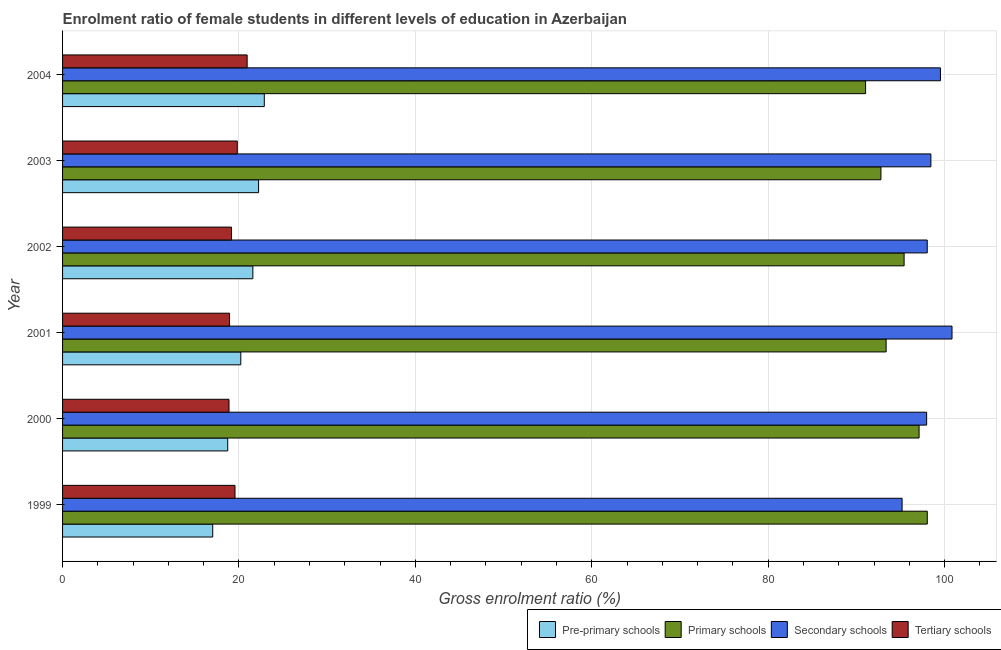How many different coloured bars are there?
Offer a terse response. 4. What is the gross enrolment ratio(male) in tertiary schools in 2001?
Provide a succinct answer. 18.93. Across all years, what is the maximum gross enrolment ratio(male) in tertiary schools?
Provide a succinct answer. 20.93. Across all years, what is the minimum gross enrolment ratio(male) in primary schools?
Your answer should be compact. 91.04. What is the total gross enrolment ratio(male) in primary schools in the graph?
Give a very brief answer. 567.75. What is the difference between the gross enrolment ratio(male) in primary schools in 2001 and that in 2004?
Keep it short and to the point. 2.33. What is the difference between the gross enrolment ratio(male) in secondary schools in 2002 and the gross enrolment ratio(male) in pre-primary schools in 2001?
Your answer should be compact. 77.83. What is the average gross enrolment ratio(male) in primary schools per year?
Make the answer very short. 94.63. In the year 2001, what is the difference between the gross enrolment ratio(male) in tertiary schools and gross enrolment ratio(male) in pre-primary schools?
Keep it short and to the point. -1.28. In how many years, is the gross enrolment ratio(male) in secondary schools greater than 84 %?
Your response must be concise. 6. What is the ratio of the gross enrolment ratio(male) in secondary schools in 1999 to that in 2003?
Offer a very short reply. 0.97. Is the gross enrolment ratio(male) in pre-primary schools in 2001 less than that in 2003?
Offer a terse response. Yes. What is the difference between the highest and the second highest gross enrolment ratio(male) in secondary schools?
Your answer should be very brief. 1.31. What is the difference between the highest and the lowest gross enrolment ratio(male) in tertiary schools?
Offer a very short reply. 2.06. In how many years, is the gross enrolment ratio(male) in pre-primary schools greater than the average gross enrolment ratio(male) in pre-primary schools taken over all years?
Your response must be concise. 3. Is the sum of the gross enrolment ratio(male) in tertiary schools in 1999 and 2003 greater than the maximum gross enrolment ratio(male) in secondary schools across all years?
Your response must be concise. No. Is it the case that in every year, the sum of the gross enrolment ratio(male) in secondary schools and gross enrolment ratio(male) in primary schools is greater than the sum of gross enrolment ratio(male) in pre-primary schools and gross enrolment ratio(male) in tertiary schools?
Your response must be concise. No. What does the 3rd bar from the top in 2004 represents?
Your answer should be very brief. Primary schools. What does the 1st bar from the bottom in 2001 represents?
Your answer should be compact. Pre-primary schools. Is it the case that in every year, the sum of the gross enrolment ratio(male) in pre-primary schools and gross enrolment ratio(male) in primary schools is greater than the gross enrolment ratio(male) in secondary schools?
Provide a short and direct response. Yes. Are all the bars in the graph horizontal?
Provide a short and direct response. Yes. How many years are there in the graph?
Offer a terse response. 6. What is the difference between two consecutive major ticks on the X-axis?
Your response must be concise. 20. Does the graph contain any zero values?
Provide a succinct answer. No. Does the graph contain grids?
Offer a very short reply. Yes. Where does the legend appear in the graph?
Offer a terse response. Bottom right. How many legend labels are there?
Your answer should be compact. 4. What is the title of the graph?
Make the answer very short. Enrolment ratio of female students in different levels of education in Azerbaijan. Does "Secondary vocational" appear as one of the legend labels in the graph?
Your answer should be compact. No. What is the label or title of the X-axis?
Provide a short and direct response. Gross enrolment ratio (%). What is the label or title of the Y-axis?
Keep it short and to the point. Year. What is the Gross enrolment ratio (%) of Pre-primary schools in 1999?
Provide a short and direct response. 17.02. What is the Gross enrolment ratio (%) in Primary schools in 1999?
Make the answer very short. 98.04. What is the Gross enrolment ratio (%) of Secondary schools in 1999?
Offer a very short reply. 95.18. What is the Gross enrolment ratio (%) in Tertiary schools in 1999?
Offer a terse response. 19.55. What is the Gross enrolment ratio (%) of Pre-primary schools in 2000?
Offer a very short reply. 18.72. What is the Gross enrolment ratio (%) of Primary schools in 2000?
Make the answer very short. 97.11. What is the Gross enrolment ratio (%) in Secondary schools in 2000?
Offer a terse response. 97.96. What is the Gross enrolment ratio (%) of Tertiary schools in 2000?
Ensure brevity in your answer.  18.87. What is the Gross enrolment ratio (%) in Pre-primary schools in 2001?
Your answer should be very brief. 20.21. What is the Gross enrolment ratio (%) of Primary schools in 2001?
Provide a succinct answer. 93.37. What is the Gross enrolment ratio (%) in Secondary schools in 2001?
Provide a short and direct response. 100.84. What is the Gross enrolment ratio (%) in Tertiary schools in 2001?
Ensure brevity in your answer.  18.93. What is the Gross enrolment ratio (%) in Pre-primary schools in 2002?
Offer a very short reply. 21.57. What is the Gross enrolment ratio (%) in Primary schools in 2002?
Your answer should be very brief. 95.41. What is the Gross enrolment ratio (%) of Secondary schools in 2002?
Provide a short and direct response. 98.03. What is the Gross enrolment ratio (%) of Tertiary schools in 2002?
Your response must be concise. 19.16. What is the Gross enrolment ratio (%) in Pre-primary schools in 2003?
Keep it short and to the point. 22.22. What is the Gross enrolment ratio (%) of Primary schools in 2003?
Provide a short and direct response. 92.78. What is the Gross enrolment ratio (%) in Secondary schools in 2003?
Offer a very short reply. 98.45. What is the Gross enrolment ratio (%) in Tertiary schools in 2003?
Your response must be concise. 19.81. What is the Gross enrolment ratio (%) in Pre-primary schools in 2004?
Keep it short and to the point. 22.87. What is the Gross enrolment ratio (%) in Primary schools in 2004?
Your answer should be compact. 91.04. What is the Gross enrolment ratio (%) of Secondary schools in 2004?
Make the answer very short. 99.53. What is the Gross enrolment ratio (%) in Tertiary schools in 2004?
Provide a short and direct response. 20.93. Across all years, what is the maximum Gross enrolment ratio (%) of Pre-primary schools?
Make the answer very short. 22.87. Across all years, what is the maximum Gross enrolment ratio (%) of Primary schools?
Give a very brief answer. 98.04. Across all years, what is the maximum Gross enrolment ratio (%) in Secondary schools?
Offer a very short reply. 100.84. Across all years, what is the maximum Gross enrolment ratio (%) in Tertiary schools?
Make the answer very short. 20.93. Across all years, what is the minimum Gross enrolment ratio (%) of Pre-primary schools?
Ensure brevity in your answer.  17.02. Across all years, what is the minimum Gross enrolment ratio (%) of Primary schools?
Provide a succinct answer. 91.04. Across all years, what is the minimum Gross enrolment ratio (%) of Secondary schools?
Your answer should be compact. 95.18. Across all years, what is the minimum Gross enrolment ratio (%) of Tertiary schools?
Your answer should be compact. 18.87. What is the total Gross enrolment ratio (%) of Pre-primary schools in the graph?
Keep it short and to the point. 122.62. What is the total Gross enrolment ratio (%) of Primary schools in the graph?
Offer a terse response. 567.75. What is the total Gross enrolment ratio (%) in Secondary schools in the graph?
Keep it short and to the point. 590. What is the total Gross enrolment ratio (%) in Tertiary schools in the graph?
Your response must be concise. 117.24. What is the difference between the Gross enrolment ratio (%) of Pre-primary schools in 1999 and that in 2000?
Your answer should be very brief. -1.7. What is the difference between the Gross enrolment ratio (%) in Primary schools in 1999 and that in 2000?
Provide a succinct answer. 0.93. What is the difference between the Gross enrolment ratio (%) of Secondary schools in 1999 and that in 2000?
Your answer should be very brief. -2.78. What is the difference between the Gross enrolment ratio (%) in Tertiary schools in 1999 and that in 2000?
Give a very brief answer. 0.68. What is the difference between the Gross enrolment ratio (%) in Pre-primary schools in 1999 and that in 2001?
Offer a terse response. -3.18. What is the difference between the Gross enrolment ratio (%) of Primary schools in 1999 and that in 2001?
Ensure brevity in your answer.  4.67. What is the difference between the Gross enrolment ratio (%) of Secondary schools in 1999 and that in 2001?
Your response must be concise. -5.66. What is the difference between the Gross enrolment ratio (%) of Tertiary schools in 1999 and that in 2001?
Make the answer very short. 0.62. What is the difference between the Gross enrolment ratio (%) of Pre-primary schools in 1999 and that in 2002?
Provide a succinct answer. -4.55. What is the difference between the Gross enrolment ratio (%) in Primary schools in 1999 and that in 2002?
Provide a short and direct response. 2.63. What is the difference between the Gross enrolment ratio (%) of Secondary schools in 1999 and that in 2002?
Offer a very short reply. -2.85. What is the difference between the Gross enrolment ratio (%) in Tertiary schools in 1999 and that in 2002?
Your answer should be compact. 0.39. What is the difference between the Gross enrolment ratio (%) in Pre-primary schools in 1999 and that in 2003?
Offer a very short reply. -5.2. What is the difference between the Gross enrolment ratio (%) in Primary schools in 1999 and that in 2003?
Your answer should be compact. 5.25. What is the difference between the Gross enrolment ratio (%) in Secondary schools in 1999 and that in 2003?
Your answer should be compact. -3.27. What is the difference between the Gross enrolment ratio (%) of Tertiary schools in 1999 and that in 2003?
Your answer should be compact. -0.26. What is the difference between the Gross enrolment ratio (%) in Pre-primary schools in 1999 and that in 2004?
Provide a succinct answer. -5.85. What is the difference between the Gross enrolment ratio (%) of Primary schools in 1999 and that in 2004?
Your response must be concise. 6.99. What is the difference between the Gross enrolment ratio (%) of Secondary schools in 1999 and that in 2004?
Provide a short and direct response. -4.35. What is the difference between the Gross enrolment ratio (%) in Tertiary schools in 1999 and that in 2004?
Provide a short and direct response. -1.38. What is the difference between the Gross enrolment ratio (%) in Pre-primary schools in 2000 and that in 2001?
Keep it short and to the point. -1.48. What is the difference between the Gross enrolment ratio (%) in Primary schools in 2000 and that in 2001?
Give a very brief answer. 3.74. What is the difference between the Gross enrolment ratio (%) of Secondary schools in 2000 and that in 2001?
Provide a short and direct response. -2.88. What is the difference between the Gross enrolment ratio (%) in Tertiary schools in 2000 and that in 2001?
Keep it short and to the point. -0.06. What is the difference between the Gross enrolment ratio (%) of Pre-primary schools in 2000 and that in 2002?
Provide a short and direct response. -2.85. What is the difference between the Gross enrolment ratio (%) in Primary schools in 2000 and that in 2002?
Ensure brevity in your answer.  1.7. What is the difference between the Gross enrolment ratio (%) of Secondary schools in 2000 and that in 2002?
Your answer should be very brief. -0.07. What is the difference between the Gross enrolment ratio (%) in Tertiary schools in 2000 and that in 2002?
Ensure brevity in your answer.  -0.29. What is the difference between the Gross enrolment ratio (%) of Pre-primary schools in 2000 and that in 2003?
Provide a succinct answer. -3.5. What is the difference between the Gross enrolment ratio (%) of Primary schools in 2000 and that in 2003?
Your answer should be very brief. 4.32. What is the difference between the Gross enrolment ratio (%) of Secondary schools in 2000 and that in 2003?
Offer a terse response. -0.48. What is the difference between the Gross enrolment ratio (%) of Tertiary schools in 2000 and that in 2003?
Give a very brief answer. -0.94. What is the difference between the Gross enrolment ratio (%) of Pre-primary schools in 2000 and that in 2004?
Provide a succinct answer. -4.15. What is the difference between the Gross enrolment ratio (%) in Primary schools in 2000 and that in 2004?
Provide a succinct answer. 6.06. What is the difference between the Gross enrolment ratio (%) in Secondary schools in 2000 and that in 2004?
Your answer should be very brief. -1.57. What is the difference between the Gross enrolment ratio (%) of Tertiary schools in 2000 and that in 2004?
Your answer should be very brief. -2.06. What is the difference between the Gross enrolment ratio (%) of Pre-primary schools in 2001 and that in 2002?
Keep it short and to the point. -1.37. What is the difference between the Gross enrolment ratio (%) in Primary schools in 2001 and that in 2002?
Keep it short and to the point. -2.04. What is the difference between the Gross enrolment ratio (%) of Secondary schools in 2001 and that in 2002?
Offer a very short reply. 2.81. What is the difference between the Gross enrolment ratio (%) in Tertiary schools in 2001 and that in 2002?
Provide a short and direct response. -0.23. What is the difference between the Gross enrolment ratio (%) of Pre-primary schools in 2001 and that in 2003?
Your answer should be compact. -2.02. What is the difference between the Gross enrolment ratio (%) in Primary schools in 2001 and that in 2003?
Provide a short and direct response. 0.59. What is the difference between the Gross enrolment ratio (%) in Secondary schools in 2001 and that in 2003?
Offer a terse response. 2.4. What is the difference between the Gross enrolment ratio (%) of Tertiary schools in 2001 and that in 2003?
Keep it short and to the point. -0.88. What is the difference between the Gross enrolment ratio (%) in Pre-primary schools in 2001 and that in 2004?
Your answer should be compact. -2.66. What is the difference between the Gross enrolment ratio (%) of Primary schools in 2001 and that in 2004?
Offer a terse response. 2.33. What is the difference between the Gross enrolment ratio (%) in Secondary schools in 2001 and that in 2004?
Your response must be concise. 1.31. What is the difference between the Gross enrolment ratio (%) in Tertiary schools in 2001 and that in 2004?
Offer a very short reply. -1.99. What is the difference between the Gross enrolment ratio (%) in Pre-primary schools in 2002 and that in 2003?
Your answer should be compact. -0.65. What is the difference between the Gross enrolment ratio (%) of Primary schools in 2002 and that in 2003?
Your answer should be compact. 2.63. What is the difference between the Gross enrolment ratio (%) of Secondary schools in 2002 and that in 2003?
Ensure brevity in your answer.  -0.41. What is the difference between the Gross enrolment ratio (%) in Tertiary schools in 2002 and that in 2003?
Provide a short and direct response. -0.65. What is the difference between the Gross enrolment ratio (%) in Pre-primary schools in 2002 and that in 2004?
Offer a terse response. -1.3. What is the difference between the Gross enrolment ratio (%) in Primary schools in 2002 and that in 2004?
Provide a short and direct response. 4.37. What is the difference between the Gross enrolment ratio (%) of Secondary schools in 2002 and that in 2004?
Your answer should be compact. -1.5. What is the difference between the Gross enrolment ratio (%) of Tertiary schools in 2002 and that in 2004?
Your answer should be very brief. -1.77. What is the difference between the Gross enrolment ratio (%) of Pre-primary schools in 2003 and that in 2004?
Your response must be concise. -0.65. What is the difference between the Gross enrolment ratio (%) in Primary schools in 2003 and that in 2004?
Your answer should be very brief. 1.74. What is the difference between the Gross enrolment ratio (%) in Secondary schools in 2003 and that in 2004?
Provide a short and direct response. -1.08. What is the difference between the Gross enrolment ratio (%) of Tertiary schools in 2003 and that in 2004?
Your answer should be very brief. -1.12. What is the difference between the Gross enrolment ratio (%) of Pre-primary schools in 1999 and the Gross enrolment ratio (%) of Primary schools in 2000?
Your answer should be very brief. -80.08. What is the difference between the Gross enrolment ratio (%) in Pre-primary schools in 1999 and the Gross enrolment ratio (%) in Secondary schools in 2000?
Your answer should be very brief. -80.94. What is the difference between the Gross enrolment ratio (%) in Pre-primary schools in 1999 and the Gross enrolment ratio (%) in Tertiary schools in 2000?
Make the answer very short. -1.85. What is the difference between the Gross enrolment ratio (%) of Primary schools in 1999 and the Gross enrolment ratio (%) of Secondary schools in 2000?
Give a very brief answer. 0.07. What is the difference between the Gross enrolment ratio (%) in Primary schools in 1999 and the Gross enrolment ratio (%) in Tertiary schools in 2000?
Offer a very short reply. 79.17. What is the difference between the Gross enrolment ratio (%) of Secondary schools in 1999 and the Gross enrolment ratio (%) of Tertiary schools in 2000?
Offer a terse response. 76.31. What is the difference between the Gross enrolment ratio (%) in Pre-primary schools in 1999 and the Gross enrolment ratio (%) in Primary schools in 2001?
Offer a terse response. -76.35. What is the difference between the Gross enrolment ratio (%) of Pre-primary schools in 1999 and the Gross enrolment ratio (%) of Secondary schools in 2001?
Make the answer very short. -83.82. What is the difference between the Gross enrolment ratio (%) in Pre-primary schools in 1999 and the Gross enrolment ratio (%) in Tertiary schools in 2001?
Provide a succinct answer. -1.91. What is the difference between the Gross enrolment ratio (%) of Primary schools in 1999 and the Gross enrolment ratio (%) of Secondary schools in 2001?
Your answer should be very brief. -2.81. What is the difference between the Gross enrolment ratio (%) in Primary schools in 1999 and the Gross enrolment ratio (%) in Tertiary schools in 2001?
Ensure brevity in your answer.  79.11. What is the difference between the Gross enrolment ratio (%) in Secondary schools in 1999 and the Gross enrolment ratio (%) in Tertiary schools in 2001?
Your answer should be very brief. 76.25. What is the difference between the Gross enrolment ratio (%) of Pre-primary schools in 1999 and the Gross enrolment ratio (%) of Primary schools in 2002?
Offer a very short reply. -78.39. What is the difference between the Gross enrolment ratio (%) of Pre-primary schools in 1999 and the Gross enrolment ratio (%) of Secondary schools in 2002?
Keep it short and to the point. -81.01. What is the difference between the Gross enrolment ratio (%) in Pre-primary schools in 1999 and the Gross enrolment ratio (%) in Tertiary schools in 2002?
Make the answer very short. -2.13. What is the difference between the Gross enrolment ratio (%) in Primary schools in 1999 and the Gross enrolment ratio (%) in Secondary schools in 2002?
Your answer should be compact. 0. What is the difference between the Gross enrolment ratio (%) in Primary schools in 1999 and the Gross enrolment ratio (%) in Tertiary schools in 2002?
Provide a short and direct response. 78.88. What is the difference between the Gross enrolment ratio (%) in Secondary schools in 1999 and the Gross enrolment ratio (%) in Tertiary schools in 2002?
Provide a short and direct response. 76.03. What is the difference between the Gross enrolment ratio (%) in Pre-primary schools in 1999 and the Gross enrolment ratio (%) in Primary schools in 2003?
Your answer should be very brief. -75.76. What is the difference between the Gross enrolment ratio (%) in Pre-primary schools in 1999 and the Gross enrolment ratio (%) in Secondary schools in 2003?
Make the answer very short. -81.42. What is the difference between the Gross enrolment ratio (%) in Pre-primary schools in 1999 and the Gross enrolment ratio (%) in Tertiary schools in 2003?
Offer a terse response. -2.78. What is the difference between the Gross enrolment ratio (%) in Primary schools in 1999 and the Gross enrolment ratio (%) in Secondary schools in 2003?
Keep it short and to the point. -0.41. What is the difference between the Gross enrolment ratio (%) in Primary schools in 1999 and the Gross enrolment ratio (%) in Tertiary schools in 2003?
Your answer should be very brief. 78.23. What is the difference between the Gross enrolment ratio (%) in Secondary schools in 1999 and the Gross enrolment ratio (%) in Tertiary schools in 2003?
Give a very brief answer. 75.37. What is the difference between the Gross enrolment ratio (%) of Pre-primary schools in 1999 and the Gross enrolment ratio (%) of Primary schools in 2004?
Give a very brief answer. -74.02. What is the difference between the Gross enrolment ratio (%) in Pre-primary schools in 1999 and the Gross enrolment ratio (%) in Secondary schools in 2004?
Your response must be concise. -82.51. What is the difference between the Gross enrolment ratio (%) in Pre-primary schools in 1999 and the Gross enrolment ratio (%) in Tertiary schools in 2004?
Ensure brevity in your answer.  -3.9. What is the difference between the Gross enrolment ratio (%) of Primary schools in 1999 and the Gross enrolment ratio (%) of Secondary schools in 2004?
Your answer should be very brief. -1.49. What is the difference between the Gross enrolment ratio (%) in Primary schools in 1999 and the Gross enrolment ratio (%) in Tertiary schools in 2004?
Ensure brevity in your answer.  77.11. What is the difference between the Gross enrolment ratio (%) of Secondary schools in 1999 and the Gross enrolment ratio (%) of Tertiary schools in 2004?
Provide a succinct answer. 74.26. What is the difference between the Gross enrolment ratio (%) of Pre-primary schools in 2000 and the Gross enrolment ratio (%) of Primary schools in 2001?
Your answer should be compact. -74.65. What is the difference between the Gross enrolment ratio (%) in Pre-primary schools in 2000 and the Gross enrolment ratio (%) in Secondary schools in 2001?
Give a very brief answer. -82.12. What is the difference between the Gross enrolment ratio (%) of Pre-primary schools in 2000 and the Gross enrolment ratio (%) of Tertiary schools in 2001?
Ensure brevity in your answer.  -0.21. What is the difference between the Gross enrolment ratio (%) in Primary schools in 2000 and the Gross enrolment ratio (%) in Secondary schools in 2001?
Ensure brevity in your answer.  -3.74. What is the difference between the Gross enrolment ratio (%) in Primary schools in 2000 and the Gross enrolment ratio (%) in Tertiary schools in 2001?
Your response must be concise. 78.18. What is the difference between the Gross enrolment ratio (%) in Secondary schools in 2000 and the Gross enrolment ratio (%) in Tertiary schools in 2001?
Your answer should be very brief. 79.03. What is the difference between the Gross enrolment ratio (%) in Pre-primary schools in 2000 and the Gross enrolment ratio (%) in Primary schools in 2002?
Offer a terse response. -76.69. What is the difference between the Gross enrolment ratio (%) of Pre-primary schools in 2000 and the Gross enrolment ratio (%) of Secondary schools in 2002?
Offer a very short reply. -79.31. What is the difference between the Gross enrolment ratio (%) of Pre-primary schools in 2000 and the Gross enrolment ratio (%) of Tertiary schools in 2002?
Your answer should be compact. -0.43. What is the difference between the Gross enrolment ratio (%) in Primary schools in 2000 and the Gross enrolment ratio (%) in Secondary schools in 2002?
Ensure brevity in your answer.  -0.93. What is the difference between the Gross enrolment ratio (%) in Primary schools in 2000 and the Gross enrolment ratio (%) in Tertiary schools in 2002?
Ensure brevity in your answer.  77.95. What is the difference between the Gross enrolment ratio (%) in Secondary schools in 2000 and the Gross enrolment ratio (%) in Tertiary schools in 2002?
Your answer should be very brief. 78.81. What is the difference between the Gross enrolment ratio (%) in Pre-primary schools in 2000 and the Gross enrolment ratio (%) in Primary schools in 2003?
Ensure brevity in your answer.  -74.06. What is the difference between the Gross enrolment ratio (%) of Pre-primary schools in 2000 and the Gross enrolment ratio (%) of Secondary schools in 2003?
Give a very brief answer. -79.72. What is the difference between the Gross enrolment ratio (%) in Pre-primary schools in 2000 and the Gross enrolment ratio (%) in Tertiary schools in 2003?
Offer a terse response. -1.08. What is the difference between the Gross enrolment ratio (%) of Primary schools in 2000 and the Gross enrolment ratio (%) of Secondary schools in 2003?
Your response must be concise. -1.34. What is the difference between the Gross enrolment ratio (%) in Primary schools in 2000 and the Gross enrolment ratio (%) in Tertiary schools in 2003?
Offer a terse response. 77.3. What is the difference between the Gross enrolment ratio (%) in Secondary schools in 2000 and the Gross enrolment ratio (%) in Tertiary schools in 2003?
Ensure brevity in your answer.  78.16. What is the difference between the Gross enrolment ratio (%) of Pre-primary schools in 2000 and the Gross enrolment ratio (%) of Primary schools in 2004?
Provide a succinct answer. -72.32. What is the difference between the Gross enrolment ratio (%) in Pre-primary schools in 2000 and the Gross enrolment ratio (%) in Secondary schools in 2004?
Give a very brief answer. -80.81. What is the difference between the Gross enrolment ratio (%) in Pre-primary schools in 2000 and the Gross enrolment ratio (%) in Tertiary schools in 2004?
Provide a short and direct response. -2.2. What is the difference between the Gross enrolment ratio (%) of Primary schools in 2000 and the Gross enrolment ratio (%) of Secondary schools in 2004?
Your answer should be very brief. -2.42. What is the difference between the Gross enrolment ratio (%) of Primary schools in 2000 and the Gross enrolment ratio (%) of Tertiary schools in 2004?
Make the answer very short. 76.18. What is the difference between the Gross enrolment ratio (%) in Secondary schools in 2000 and the Gross enrolment ratio (%) in Tertiary schools in 2004?
Provide a succinct answer. 77.04. What is the difference between the Gross enrolment ratio (%) of Pre-primary schools in 2001 and the Gross enrolment ratio (%) of Primary schools in 2002?
Offer a terse response. -75.2. What is the difference between the Gross enrolment ratio (%) of Pre-primary schools in 2001 and the Gross enrolment ratio (%) of Secondary schools in 2002?
Give a very brief answer. -77.83. What is the difference between the Gross enrolment ratio (%) of Pre-primary schools in 2001 and the Gross enrolment ratio (%) of Tertiary schools in 2002?
Ensure brevity in your answer.  1.05. What is the difference between the Gross enrolment ratio (%) of Primary schools in 2001 and the Gross enrolment ratio (%) of Secondary schools in 2002?
Ensure brevity in your answer.  -4.66. What is the difference between the Gross enrolment ratio (%) in Primary schools in 2001 and the Gross enrolment ratio (%) in Tertiary schools in 2002?
Offer a very short reply. 74.22. What is the difference between the Gross enrolment ratio (%) in Secondary schools in 2001 and the Gross enrolment ratio (%) in Tertiary schools in 2002?
Ensure brevity in your answer.  81.69. What is the difference between the Gross enrolment ratio (%) in Pre-primary schools in 2001 and the Gross enrolment ratio (%) in Primary schools in 2003?
Your answer should be compact. -72.58. What is the difference between the Gross enrolment ratio (%) of Pre-primary schools in 2001 and the Gross enrolment ratio (%) of Secondary schools in 2003?
Ensure brevity in your answer.  -78.24. What is the difference between the Gross enrolment ratio (%) of Pre-primary schools in 2001 and the Gross enrolment ratio (%) of Tertiary schools in 2003?
Offer a very short reply. 0.4. What is the difference between the Gross enrolment ratio (%) in Primary schools in 2001 and the Gross enrolment ratio (%) in Secondary schools in 2003?
Provide a short and direct response. -5.08. What is the difference between the Gross enrolment ratio (%) in Primary schools in 2001 and the Gross enrolment ratio (%) in Tertiary schools in 2003?
Your answer should be compact. 73.56. What is the difference between the Gross enrolment ratio (%) of Secondary schools in 2001 and the Gross enrolment ratio (%) of Tertiary schools in 2003?
Provide a succinct answer. 81.03. What is the difference between the Gross enrolment ratio (%) of Pre-primary schools in 2001 and the Gross enrolment ratio (%) of Primary schools in 2004?
Ensure brevity in your answer.  -70.84. What is the difference between the Gross enrolment ratio (%) in Pre-primary schools in 2001 and the Gross enrolment ratio (%) in Secondary schools in 2004?
Provide a short and direct response. -79.32. What is the difference between the Gross enrolment ratio (%) in Pre-primary schools in 2001 and the Gross enrolment ratio (%) in Tertiary schools in 2004?
Provide a succinct answer. -0.72. What is the difference between the Gross enrolment ratio (%) of Primary schools in 2001 and the Gross enrolment ratio (%) of Secondary schools in 2004?
Offer a very short reply. -6.16. What is the difference between the Gross enrolment ratio (%) in Primary schools in 2001 and the Gross enrolment ratio (%) in Tertiary schools in 2004?
Provide a succinct answer. 72.45. What is the difference between the Gross enrolment ratio (%) in Secondary schools in 2001 and the Gross enrolment ratio (%) in Tertiary schools in 2004?
Your response must be concise. 79.92. What is the difference between the Gross enrolment ratio (%) in Pre-primary schools in 2002 and the Gross enrolment ratio (%) in Primary schools in 2003?
Provide a short and direct response. -71.21. What is the difference between the Gross enrolment ratio (%) in Pre-primary schools in 2002 and the Gross enrolment ratio (%) in Secondary schools in 2003?
Ensure brevity in your answer.  -76.87. What is the difference between the Gross enrolment ratio (%) of Pre-primary schools in 2002 and the Gross enrolment ratio (%) of Tertiary schools in 2003?
Offer a terse response. 1.77. What is the difference between the Gross enrolment ratio (%) of Primary schools in 2002 and the Gross enrolment ratio (%) of Secondary schools in 2003?
Keep it short and to the point. -3.04. What is the difference between the Gross enrolment ratio (%) in Primary schools in 2002 and the Gross enrolment ratio (%) in Tertiary schools in 2003?
Provide a succinct answer. 75.6. What is the difference between the Gross enrolment ratio (%) of Secondary schools in 2002 and the Gross enrolment ratio (%) of Tertiary schools in 2003?
Your response must be concise. 78.23. What is the difference between the Gross enrolment ratio (%) of Pre-primary schools in 2002 and the Gross enrolment ratio (%) of Primary schools in 2004?
Offer a very short reply. -69.47. What is the difference between the Gross enrolment ratio (%) of Pre-primary schools in 2002 and the Gross enrolment ratio (%) of Secondary schools in 2004?
Your answer should be compact. -77.96. What is the difference between the Gross enrolment ratio (%) of Pre-primary schools in 2002 and the Gross enrolment ratio (%) of Tertiary schools in 2004?
Your answer should be very brief. 0.65. What is the difference between the Gross enrolment ratio (%) in Primary schools in 2002 and the Gross enrolment ratio (%) in Secondary schools in 2004?
Make the answer very short. -4.12. What is the difference between the Gross enrolment ratio (%) of Primary schools in 2002 and the Gross enrolment ratio (%) of Tertiary schools in 2004?
Keep it short and to the point. 74.48. What is the difference between the Gross enrolment ratio (%) in Secondary schools in 2002 and the Gross enrolment ratio (%) in Tertiary schools in 2004?
Provide a succinct answer. 77.11. What is the difference between the Gross enrolment ratio (%) in Pre-primary schools in 2003 and the Gross enrolment ratio (%) in Primary schools in 2004?
Ensure brevity in your answer.  -68.82. What is the difference between the Gross enrolment ratio (%) in Pre-primary schools in 2003 and the Gross enrolment ratio (%) in Secondary schools in 2004?
Your answer should be compact. -77.31. What is the difference between the Gross enrolment ratio (%) of Pre-primary schools in 2003 and the Gross enrolment ratio (%) of Tertiary schools in 2004?
Make the answer very short. 1.3. What is the difference between the Gross enrolment ratio (%) of Primary schools in 2003 and the Gross enrolment ratio (%) of Secondary schools in 2004?
Provide a short and direct response. -6.75. What is the difference between the Gross enrolment ratio (%) in Primary schools in 2003 and the Gross enrolment ratio (%) in Tertiary schools in 2004?
Your response must be concise. 71.86. What is the difference between the Gross enrolment ratio (%) in Secondary schools in 2003 and the Gross enrolment ratio (%) in Tertiary schools in 2004?
Offer a very short reply. 77.52. What is the average Gross enrolment ratio (%) in Pre-primary schools per year?
Your answer should be very brief. 20.44. What is the average Gross enrolment ratio (%) in Primary schools per year?
Provide a short and direct response. 94.63. What is the average Gross enrolment ratio (%) in Secondary schools per year?
Your answer should be very brief. 98.33. What is the average Gross enrolment ratio (%) of Tertiary schools per year?
Provide a succinct answer. 19.54. In the year 1999, what is the difference between the Gross enrolment ratio (%) of Pre-primary schools and Gross enrolment ratio (%) of Primary schools?
Your response must be concise. -81.01. In the year 1999, what is the difference between the Gross enrolment ratio (%) in Pre-primary schools and Gross enrolment ratio (%) in Secondary schools?
Give a very brief answer. -78.16. In the year 1999, what is the difference between the Gross enrolment ratio (%) in Pre-primary schools and Gross enrolment ratio (%) in Tertiary schools?
Your response must be concise. -2.53. In the year 1999, what is the difference between the Gross enrolment ratio (%) of Primary schools and Gross enrolment ratio (%) of Secondary schools?
Provide a succinct answer. 2.86. In the year 1999, what is the difference between the Gross enrolment ratio (%) of Primary schools and Gross enrolment ratio (%) of Tertiary schools?
Offer a very short reply. 78.49. In the year 1999, what is the difference between the Gross enrolment ratio (%) in Secondary schools and Gross enrolment ratio (%) in Tertiary schools?
Provide a short and direct response. 75.63. In the year 2000, what is the difference between the Gross enrolment ratio (%) in Pre-primary schools and Gross enrolment ratio (%) in Primary schools?
Ensure brevity in your answer.  -78.38. In the year 2000, what is the difference between the Gross enrolment ratio (%) in Pre-primary schools and Gross enrolment ratio (%) in Secondary schools?
Offer a very short reply. -79.24. In the year 2000, what is the difference between the Gross enrolment ratio (%) in Pre-primary schools and Gross enrolment ratio (%) in Tertiary schools?
Your response must be concise. -0.15. In the year 2000, what is the difference between the Gross enrolment ratio (%) of Primary schools and Gross enrolment ratio (%) of Secondary schools?
Make the answer very short. -0.86. In the year 2000, what is the difference between the Gross enrolment ratio (%) of Primary schools and Gross enrolment ratio (%) of Tertiary schools?
Provide a short and direct response. 78.24. In the year 2000, what is the difference between the Gross enrolment ratio (%) of Secondary schools and Gross enrolment ratio (%) of Tertiary schools?
Your answer should be very brief. 79.09. In the year 2001, what is the difference between the Gross enrolment ratio (%) in Pre-primary schools and Gross enrolment ratio (%) in Primary schools?
Your response must be concise. -73.17. In the year 2001, what is the difference between the Gross enrolment ratio (%) of Pre-primary schools and Gross enrolment ratio (%) of Secondary schools?
Offer a very short reply. -80.64. In the year 2001, what is the difference between the Gross enrolment ratio (%) in Pre-primary schools and Gross enrolment ratio (%) in Tertiary schools?
Ensure brevity in your answer.  1.28. In the year 2001, what is the difference between the Gross enrolment ratio (%) in Primary schools and Gross enrolment ratio (%) in Secondary schools?
Keep it short and to the point. -7.47. In the year 2001, what is the difference between the Gross enrolment ratio (%) in Primary schools and Gross enrolment ratio (%) in Tertiary schools?
Your response must be concise. 74.44. In the year 2001, what is the difference between the Gross enrolment ratio (%) in Secondary schools and Gross enrolment ratio (%) in Tertiary schools?
Offer a very short reply. 81.91. In the year 2002, what is the difference between the Gross enrolment ratio (%) in Pre-primary schools and Gross enrolment ratio (%) in Primary schools?
Make the answer very short. -73.84. In the year 2002, what is the difference between the Gross enrolment ratio (%) in Pre-primary schools and Gross enrolment ratio (%) in Secondary schools?
Ensure brevity in your answer.  -76.46. In the year 2002, what is the difference between the Gross enrolment ratio (%) of Pre-primary schools and Gross enrolment ratio (%) of Tertiary schools?
Ensure brevity in your answer.  2.42. In the year 2002, what is the difference between the Gross enrolment ratio (%) in Primary schools and Gross enrolment ratio (%) in Secondary schools?
Your answer should be very brief. -2.62. In the year 2002, what is the difference between the Gross enrolment ratio (%) of Primary schools and Gross enrolment ratio (%) of Tertiary schools?
Your answer should be compact. 76.25. In the year 2002, what is the difference between the Gross enrolment ratio (%) of Secondary schools and Gross enrolment ratio (%) of Tertiary schools?
Give a very brief answer. 78.88. In the year 2003, what is the difference between the Gross enrolment ratio (%) in Pre-primary schools and Gross enrolment ratio (%) in Primary schools?
Offer a terse response. -70.56. In the year 2003, what is the difference between the Gross enrolment ratio (%) in Pre-primary schools and Gross enrolment ratio (%) in Secondary schools?
Your answer should be very brief. -76.22. In the year 2003, what is the difference between the Gross enrolment ratio (%) in Pre-primary schools and Gross enrolment ratio (%) in Tertiary schools?
Keep it short and to the point. 2.41. In the year 2003, what is the difference between the Gross enrolment ratio (%) in Primary schools and Gross enrolment ratio (%) in Secondary schools?
Offer a terse response. -5.66. In the year 2003, what is the difference between the Gross enrolment ratio (%) in Primary schools and Gross enrolment ratio (%) in Tertiary schools?
Make the answer very short. 72.98. In the year 2003, what is the difference between the Gross enrolment ratio (%) in Secondary schools and Gross enrolment ratio (%) in Tertiary schools?
Make the answer very short. 78.64. In the year 2004, what is the difference between the Gross enrolment ratio (%) of Pre-primary schools and Gross enrolment ratio (%) of Primary schools?
Provide a short and direct response. -68.17. In the year 2004, what is the difference between the Gross enrolment ratio (%) of Pre-primary schools and Gross enrolment ratio (%) of Secondary schools?
Offer a very short reply. -76.66. In the year 2004, what is the difference between the Gross enrolment ratio (%) of Pre-primary schools and Gross enrolment ratio (%) of Tertiary schools?
Give a very brief answer. 1.95. In the year 2004, what is the difference between the Gross enrolment ratio (%) in Primary schools and Gross enrolment ratio (%) in Secondary schools?
Make the answer very short. -8.49. In the year 2004, what is the difference between the Gross enrolment ratio (%) of Primary schools and Gross enrolment ratio (%) of Tertiary schools?
Provide a succinct answer. 70.12. In the year 2004, what is the difference between the Gross enrolment ratio (%) in Secondary schools and Gross enrolment ratio (%) in Tertiary schools?
Your response must be concise. 78.61. What is the ratio of the Gross enrolment ratio (%) in Pre-primary schools in 1999 to that in 2000?
Your answer should be compact. 0.91. What is the ratio of the Gross enrolment ratio (%) in Primary schools in 1999 to that in 2000?
Your answer should be very brief. 1.01. What is the ratio of the Gross enrolment ratio (%) in Secondary schools in 1999 to that in 2000?
Offer a terse response. 0.97. What is the ratio of the Gross enrolment ratio (%) in Tertiary schools in 1999 to that in 2000?
Make the answer very short. 1.04. What is the ratio of the Gross enrolment ratio (%) in Pre-primary schools in 1999 to that in 2001?
Your answer should be compact. 0.84. What is the ratio of the Gross enrolment ratio (%) of Secondary schools in 1999 to that in 2001?
Give a very brief answer. 0.94. What is the ratio of the Gross enrolment ratio (%) in Tertiary schools in 1999 to that in 2001?
Ensure brevity in your answer.  1.03. What is the ratio of the Gross enrolment ratio (%) in Pre-primary schools in 1999 to that in 2002?
Keep it short and to the point. 0.79. What is the ratio of the Gross enrolment ratio (%) of Primary schools in 1999 to that in 2002?
Offer a terse response. 1.03. What is the ratio of the Gross enrolment ratio (%) in Secondary schools in 1999 to that in 2002?
Give a very brief answer. 0.97. What is the ratio of the Gross enrolment ratio (%) of Tertiary schools in 1999 to that in 2002?
Your answer should be very brief. 1.02. What is the ratio of the Gross enrolment ratio (%) in Pre-primary schools in 1999 to that in 2003?
Your answer should be very brief. 0.77. What is the ratio of the Gross enrolment ratio (%) of Primary schools in 1999 to that in 2003?
Your response must be concise. 1.06. What is the ratio of the Gross enrolment ratio (%) of Secondary schools in 1999 to that in 2003?
Offer a terse response. 0.97. What is the ratio of the Gross enrolment ratio (%) of Tertiary schools in 1999 to that in 2003?
Your answer should be compact. 0.99. What is the ratio of the Gross enrolment ratio (%) in Pre-primary schools in 1999 to that in 2004?
Provide a succinct answer. 0.74. What is the ratio of the Gross enrolment ratio (%) in Primary schools in 1999 to that in 2004?
Your response must be concise. 1.08. What is the ratio of the Gross enrolment ratio (%) of Secondary schools in 1999 to that in 2004?
Give a very brief answer. 0.96. What is the ratio of the Gross enrolment ratio (%) of Tertiary schools in 1999 to that in 2004?
Offer a very short reply. 0.93. What is the ratio of the Gross enrolment ratio (%) of Pre-primary schools in 2000 to that in 2001?
Provide a succinct answer. 0.93. What is the ratio of the Gross enrolment ratio (%) of Primary schools in 2000 to that in 2001?
Your answer should be very brief. 1.04. What is the ratio of the Gross enrolment ratio (%) in Secondary schools in 2000 to that in 2001?
Keep it short and to the point. 0.97. What is the ratio of the Gross enrolment ratio (%) of Pre-primary schools in 2000 to that in 2002?
Provide a short and direct response. 0.87. What is the ratio of the Gross enrolment ratio (%) in Primary schools in 2000 to that in 2002?
Ensure brevity in your answer.  1.02. What is the ratio of the Gross enrolment ratio (%) of Tertiary schools in 2000 to that in 2002?
Keep it short and to the point. 0.99. What is the ratio of the Gross enrolment ratio (%) of Pre-primary schools in 2000 to that in 2003?
Your response must be concise. 0.84. What is the ratio of the Gross enrolment ratio (%) in Primary schools in 2000 to that in 2003?
Provide a succinct answer. 1.05. What is the ratio of the Gross enrolment ratio (%) of Tertiary schools in 2000 to that in 2003?
Keep it short and to the point. 0.95. What is the ratio of the Gross enrolment ratio (%) in Pre-primary schools in 2000 to that in 2004?
Provide a short and direct response. 0.82. What is the ratio of the Gross enrolment ratio (%) in Primary schools in 2000 to that in 2004?
Offer a terse response. 1.07. What is the ratio of the Gross enrolment ratio (%) in Secondary schools in 2000 to that in 2004?
Your response must be concise. 0.98. What is the ratio of the Gross enrolment ratio (%) in Tertiary schools in 2000 to that in 2004?
Ensure brevity in your answer.  0.9. What is the ratio of the Gross enrolment ratio (%) of Pre-primary schools in 2001 to that in 2002?
Offer a very short reply. 0.94. What is the ratio of the Gross enrolment ratio (%) of Primary schools in 2001 to that in 2002?
Offer a terse response. 0.98. What is the ratio of the Gross enrolment ratio (%) of Secondary schools in 2001 to that in 2002?
Ensure brevity in your answer.  1.03. What is the ratio of the Gross enrolment ratio (%) in Pre-primary schools in 2001 to that in 2003?
Your answer should be very brief. 0.91. What is the ratio of the Gross enrolment ratio (%) of Secondary schools in 2001 to that in 2003?
Keep it short and to the point. 1.02. What is the ratio of the Gross enrolment ratio (%) in Tertiary schools in 2001 to that in 2003?
Your response must be concise. 0.96. What is the ratio of the Gross enrolment ratio (%) in Pre-primary schools in 2001 to that in 2004?
Provide a succinct answer. 0.88. What is the ratio of the Gross enrolment ratio (%) of Primary schools in 2001 to that in 2004?
Offer a terse response. 1.03. What is the ratio of the Gross enrolment ratio (%) in Secondary schools in 2001 to that in 2004?
Your answer should be very brief. 1.01. What is the ratio of the Gross enrolment ratio (%) of Tertiary schools in 2001 to that in 2004?
Your answer should be very brief. 0.9. What is the ratio of the Gross enrolment ratio (%) in Pre-primary schools in 2002 to that in 2003?
Your response must be concise. 0.97. What is the ratio of the Gross enrolment ratio (%) of Primary schools in 2002 to that in 2003?
Provide a succinct answer. 1.03. What is the ratio of the Gross enrolment ratio (%) of Tertiary schools in 2002 to that in 2003?
Provide a succinct answer. 0.97. What is the ratio of the Gross enrolment ratio (%) in Pre-primary schools in 2002 to that in 2004?
Offer a very short reply. 0.94. What is the ratio of the Gross enrolment ratio (%) of Primary schools in 2002 to that in 2004?
Your answer should be very brief. 1.05. What is the ratio of the Gross enrolment ratio (%) in Tertiary schools in 2002 to that in 2004?
Offer a very short reply. 0.92. What is the ratio of the Gross enrolment ratio (%) of Pre-primary schools in 2003 to that in 2004?
Your answer should be compact. 0.97. What is the ratio of the Gross enrolment ratio (%) in Primary schools in 2003 to that in 2004?
Offer a very short reply. 1.02. What is the ratio of the Gross enrolment ratio (%) of Tertiary schools in 2003 to that in 2004?
Your response must be concise. 0.95. What is the difference between the highest and the second highest Gross enrolment ratio (%) in Pre-primary schools?
Provide a succinct answer. 0.65. What is the difference between the highest and the second highest Gross enrolment ratio (%) in Secondary schools?
Your answer should be compact. 1.31. What is the difference between the highest and the second highest Gross enrolment ratio (%) of Tertiary schools?
Offer a very short reply. 1.12. What is the difference between the highest and the lowest Gross enrolment ratio (%) in Pre-primary schools?
Give a very brief answer. 5.85. What is the difference between the highest and the lowest Gross enrolment ratio (%) of Primary schools?
Your answer should be compact. 6.99. What is the difference between the highest and the lowest Gross enrolment ratio (%) in Secondary schools?
Your answer should be compact. 5.66. What is the difference between the highest and the lowest Gross enrolment ratio (%) of Tertiary schools?
Provide a short and direct response. 2.06. 